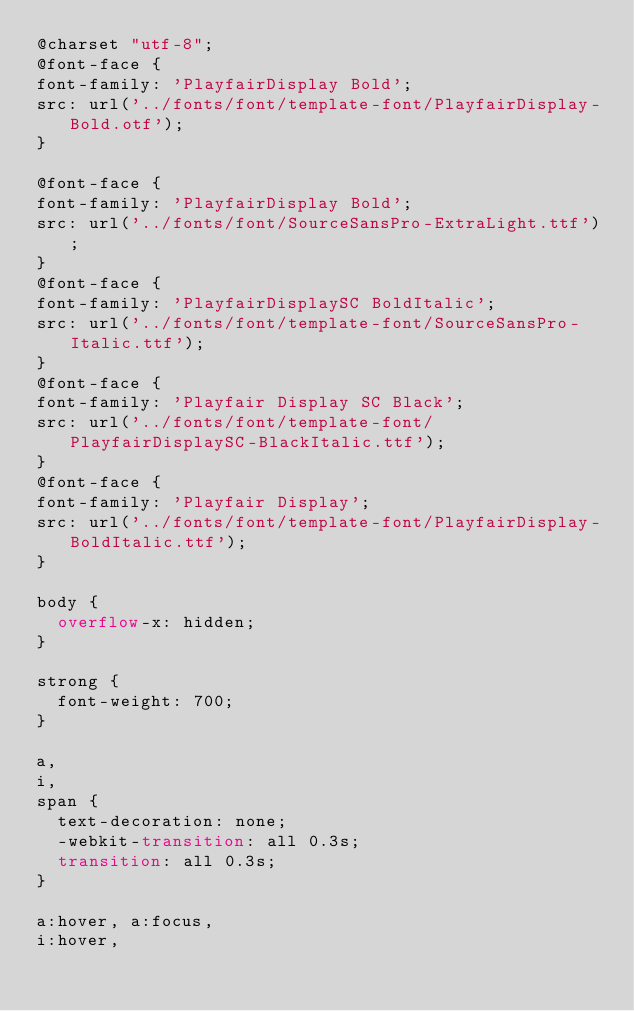<code> <loc_0><loc_0><loc_500><loc_500><_CSS_>@charset "utf-8";
@font-face {
font-family: 'PlayfairDisplay Bold';
src: url('../fonts/font/template-font/PlayfairDisplay-Bold.otf');
}

@font-face {
font-family: 'PlayfairDisplay Bold';
src: url('../fonts/font/SourceSansPro-ExtraLight.ttf');
}
@font-face {
font-family: 'PlayfairDisplaySC BoldItalic';
src: url('../fonts/font/template-font/SourceSansPro-Italic.ttf');
}
@font-face {
font-family: 'Playfair Display SC Black';
src: url('../fonts/font/template-font/PlayfairDisplaySC-BlackItalic.ttf');
}
@font-face {
font-family: 'Playfair Display';
src: url('../fonts/font/template-font/PlayfairDisplay-BoldItalic.ttf');
}

body {
  overflow-x: hidden;
}

strong {
  font-weight: 700;
}

a,
i,
span { 
  text-decoration: none;
  -webkit-transition: all 0.3s;
  transition: all 0.3s;
}

a:hover, a:focus,
i:hover,</code> 